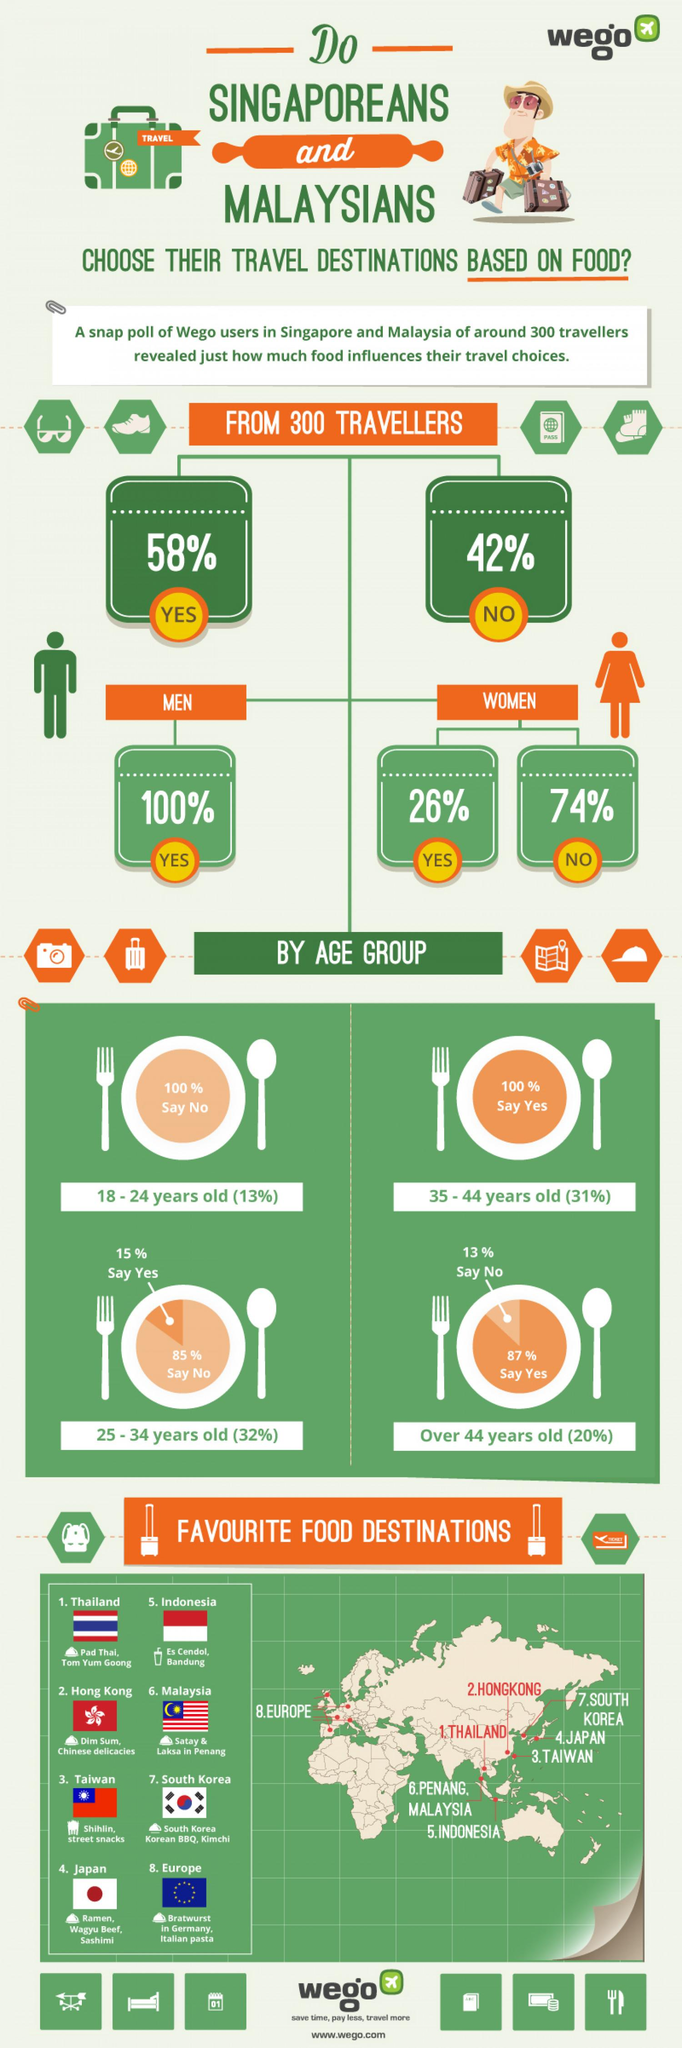Give some essential details in this illustration. According to a survey, 15% of people aged between 25-34 choose travel destinations based on food, which is higher than the other two options, 85% and 32%. The seven food destinations belong to the continent of Asia. According to the survey, 100% of people between the age group 35-44 do not choose travel destinations based on food. According to the given information, 13% of people over the age of 44 do not choose travel destinations based on food. According to the given data, 100% of people between the age group 18-24 choose travel destinations based on food. 